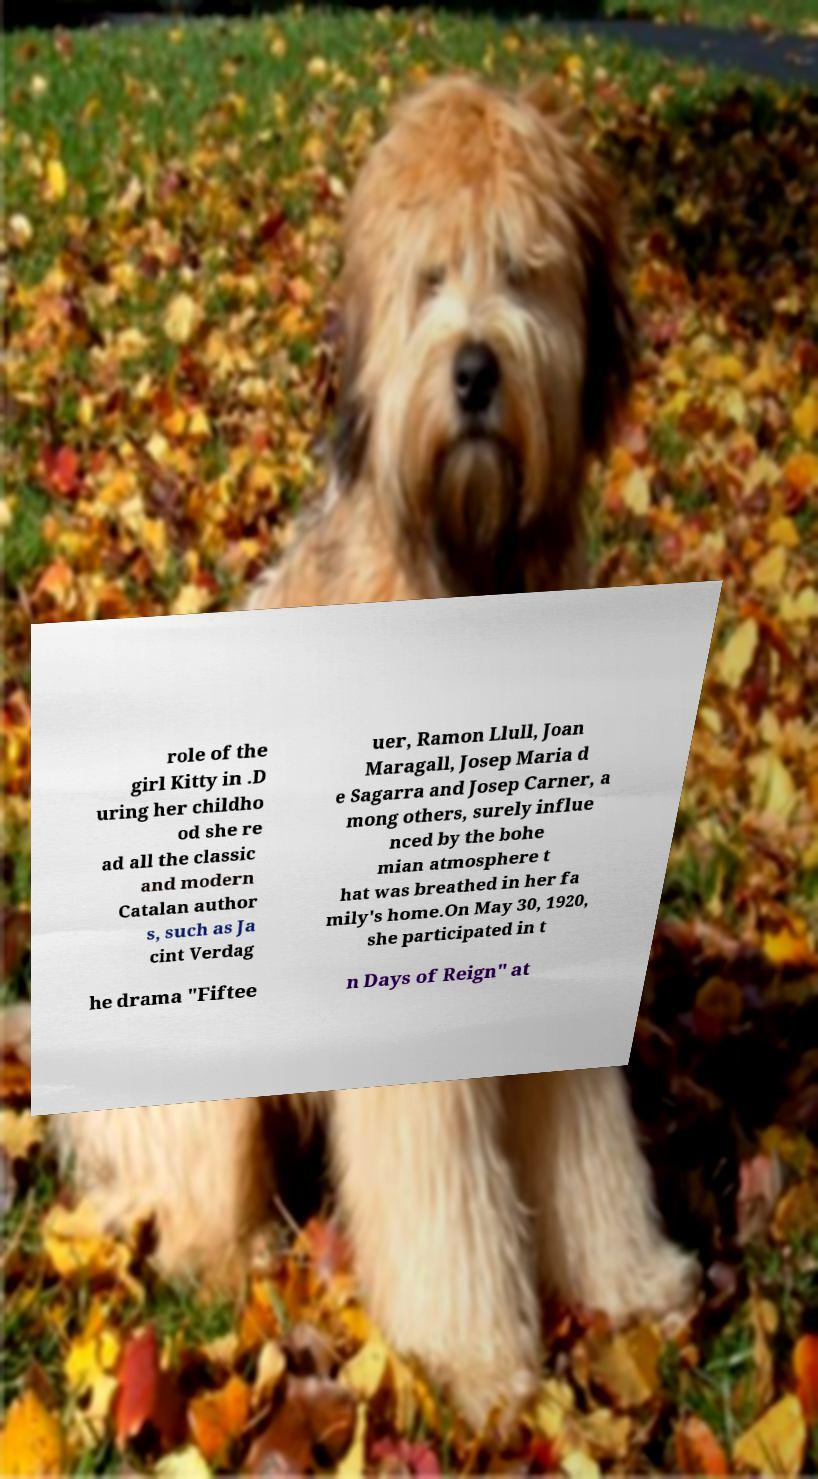Could you assist in decoding the text presented in this image and type it out clearly? role of the girl Kitty in .D uring her childho od she re ad all the classic and modern Catalan author s, such as Ja cint Verdag uer, Ramon Llull, Joan Maragall, Josep Maria d e Sagarra and Josep Carner, a mong others, surely influe nced by the bohe mian atmosphere t hat was breathed in her fa mily's home.On May 30, 1920, she participated in t he drama "Fiftee n Days of Reign" at 